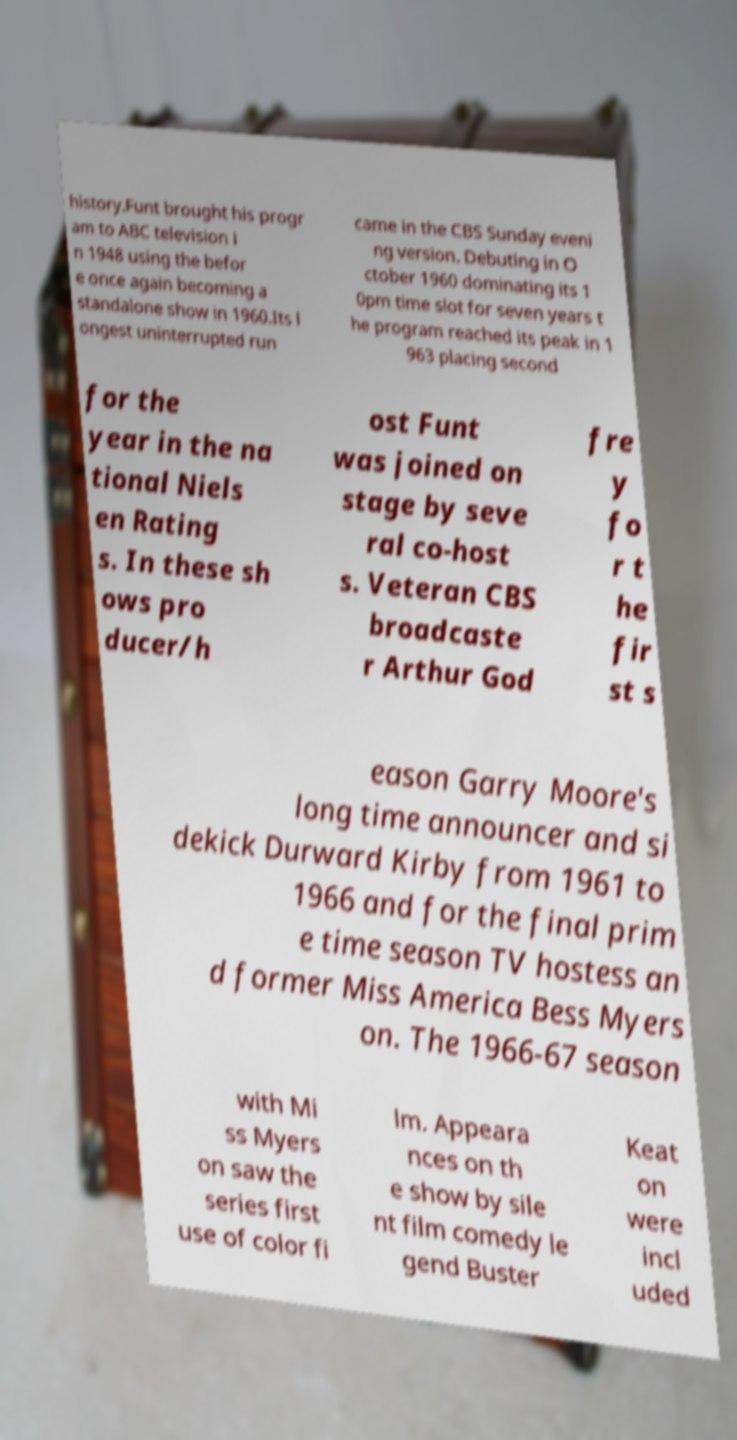Please identify and transcribe the text found in this image. history.Funt brought his progr am to ABC television i n 1948 using the befor e once again becoming a standalone show in 1960.Its l ongest uninterrupted run came in the CBS Sunday eveni ng version. Debuting in O ctober 1960 dominating its 1 0pm time slot for seven years t he program reached its peak in 1 963 placing second for the year in the na tional Niels en Rating s. In these sh ows pro ducer/h ost Funt was joined on stage by seve ral co-host s. Veteran CBS broadcaste r Arthur God fre y fo r t he fir st s eason Garry Moore's long time announcer and si dekick Durward Kirby from 1961 to 1966 and for the final prim e time season TV hostess an d former Miss America Bess Myers on. The 1966-67 season with Mi ss Myers on saw the series first use of color fi lm. Appeara nces on th e show by sile nt film comedy le gend Buster Keat on were incl uded 